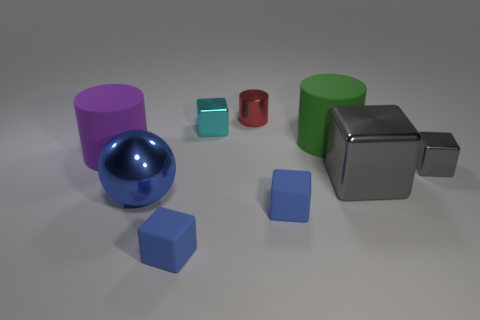There is a small shiny thing that is on the right side of the small cylinder; what shape is it?
Your response must be concise. Cube. There is a thing that is the same color as the large shiny cube; what is its size?
Provide a short and direct response. Small. What is the green cylinder made of?
Keep it short and to the point. Rubber. What is the color of the cylinder that is the same size as the cyan thing?
Your response must be concise. Red. There is a small metallic thing that is the same color as the large block; what shape is it?
Provide a succinct answer. Cube. Is the big purple rubber thing the same shape as the big blue shiny object?
Your response must be concise. No. There is a small object that is on the left side of the red shiny thing and in front of the large metal sphere; what is its material?
Provide a succinct answer. Rubber. What size is the red metal cylinder?
Offer a very short reply. Small. There is a small object that is the same shape as the big green object; what color is it?
Your answer should be very brief. Red. Are there any other things that are the same color as the metal sphere?
Your answer should be very brief. Yes. 